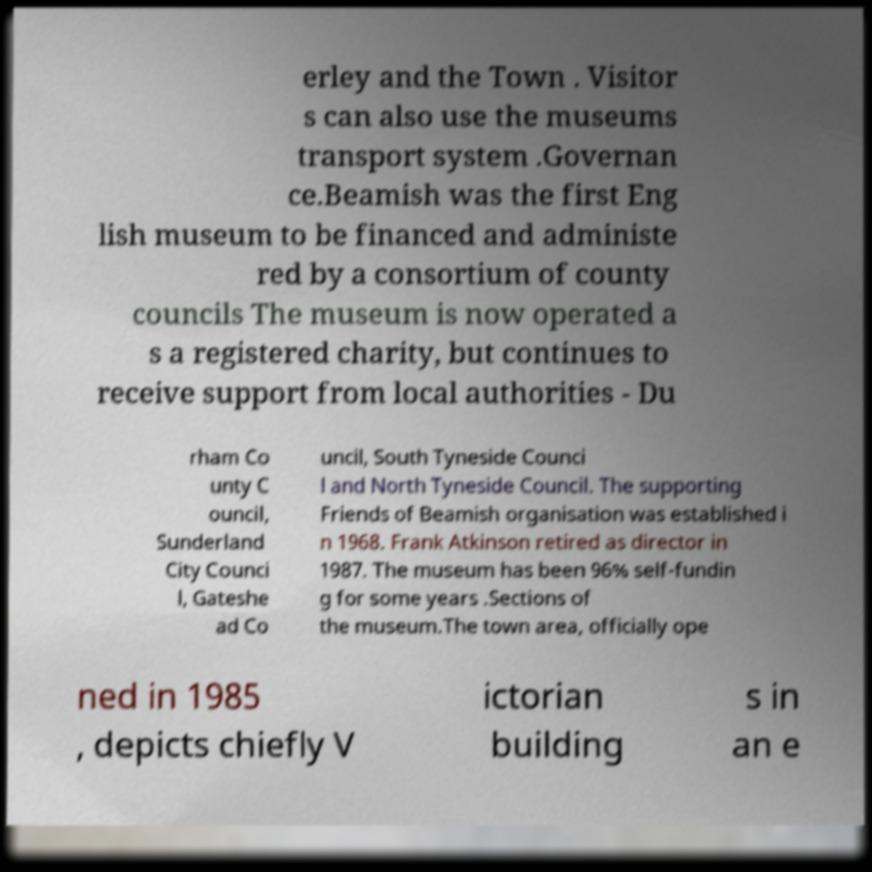Can you read and provide the text displayed in the image?This photo seems to have some interesting text. Can you extract and type it out for me? erley and the Town . Visitor s can also use the museums transport system .Governan ce.Beamish was the first Eng lish museum to be financed and administe red by a consortium of county councils The museum is now operated a s a registered charity, but continues to receive support from local authorities - Du rham Co unty C ouncil, Sunderland City Counci l, Gateshe ad Co uncil, South Tyneside Counci l and North Tyneside Council. The supporting Friends of Beamish organisation was established i n 1968. Frank Atkinson retired as director in 1987. The museum has been 96% self-fundin g for some years .Sections of the museum.The town area, officially ope ned in 1985 , depicts chiefly V ictorian building s in an e 